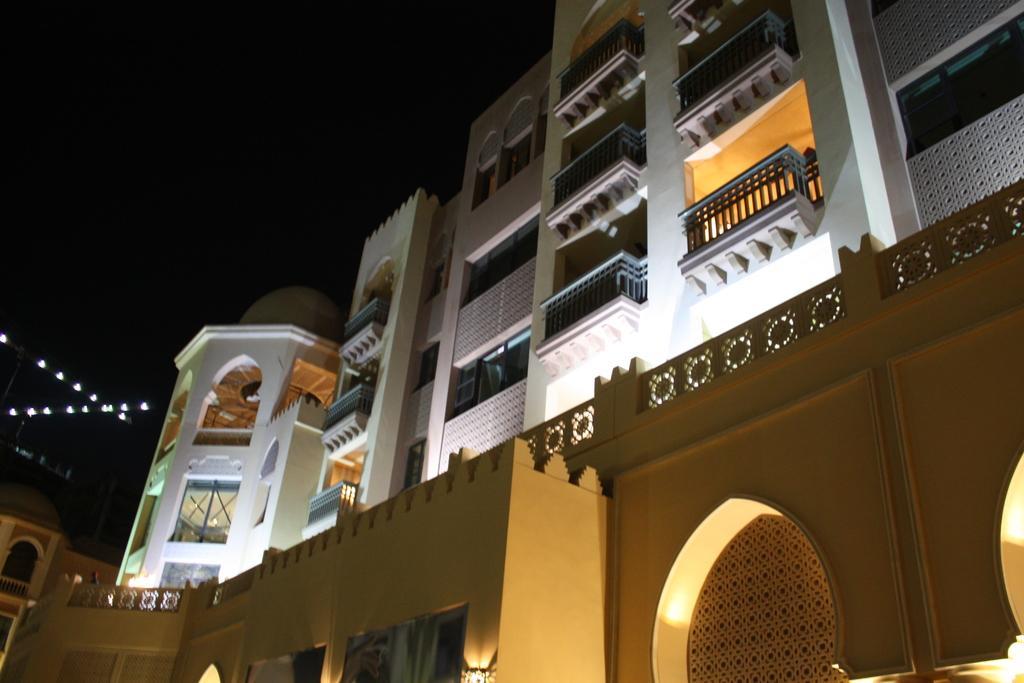Describe this image in one or two sentences. In the picture I can see buildings, I can see the lights and the dark sky in the background. 